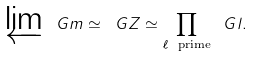<formula> <loc_0><loc_0><loc_500><loc_500>\varprojlim \ G m \simeq \ G Z \simeq \prod _ { \ell \ \text {prime} } \ G l .</formula> 